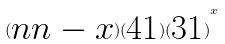Convert formula to latex. <formula><loc_0><loc_0><loc_500><loc_500>( \begin{matrix} n n - x \end{matrix} ) ( \begin{matrix} 4 1 \end{matrix} ) { ( \begin{matrix} 3 1 \end{matrix} ) } ^ { x }</formula> 